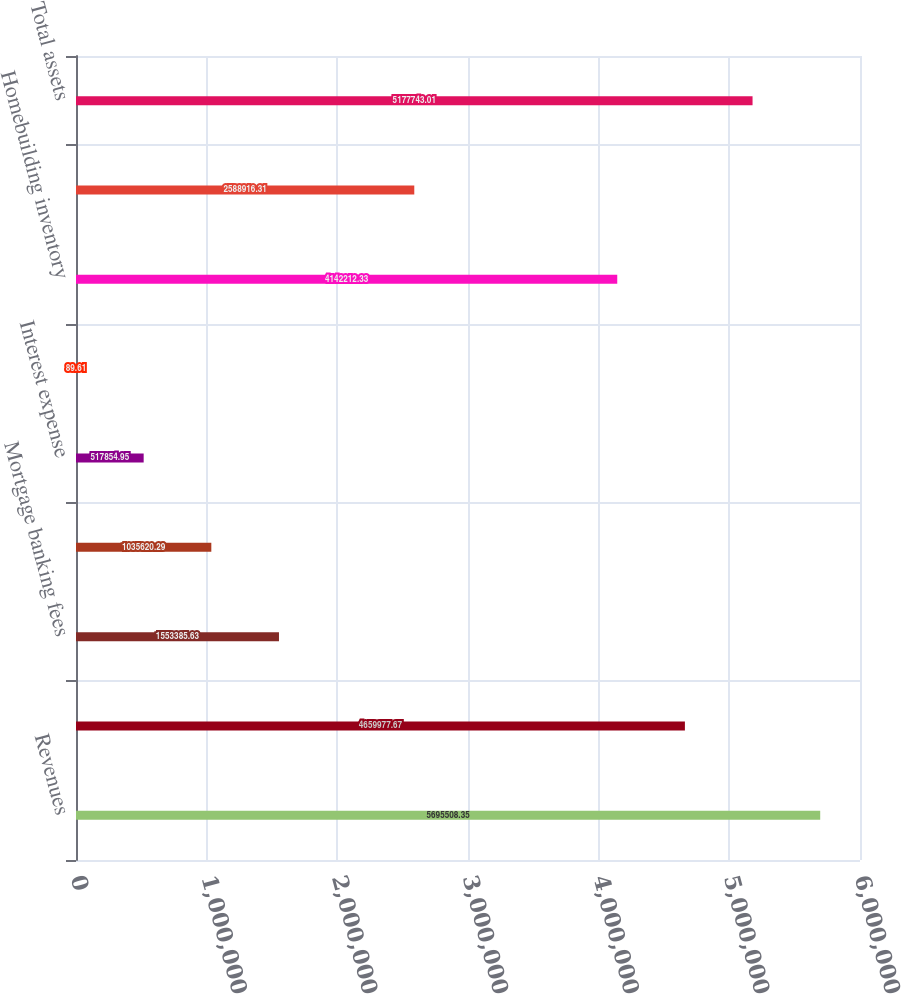<chart> <loc_0><loc_0><loc_500><loc_500><bar_chart><fcel>Revenues<fcel>Gross profit<fcel>Mortgage banking fees<fcel>Interest income<fcel>Interest expense<fcel>Income from continuing<fcel>Homebuilding inventory<fcel>Contract land deposits net<fcel>Total assets<nl><fcel>5.69551e+06<fcel>4.65998e+06<fcel>1.55339e+06<fcel>1.03562e+06<fcel>517855<fcel>89.61<fcel>4.14221e+06<fcel>2.58892e+06<fcel>5.17774e+06<nl></chart> 